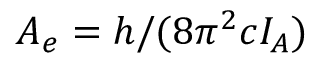Convert formula to latex. <formula><loc_0><loc_0><loc_500><loc_500>A _ { e } = h / ( 8 \pi ^ { 2 } c I _ { A } )</formula> 